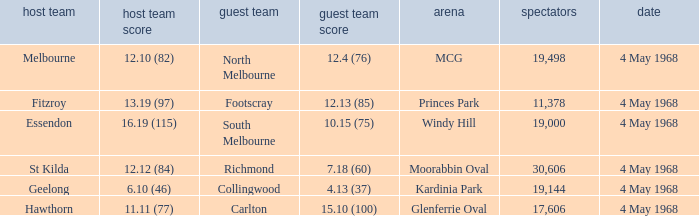What team played at Moorabbin Oval to a crowd of 19,144? St Kilda. 